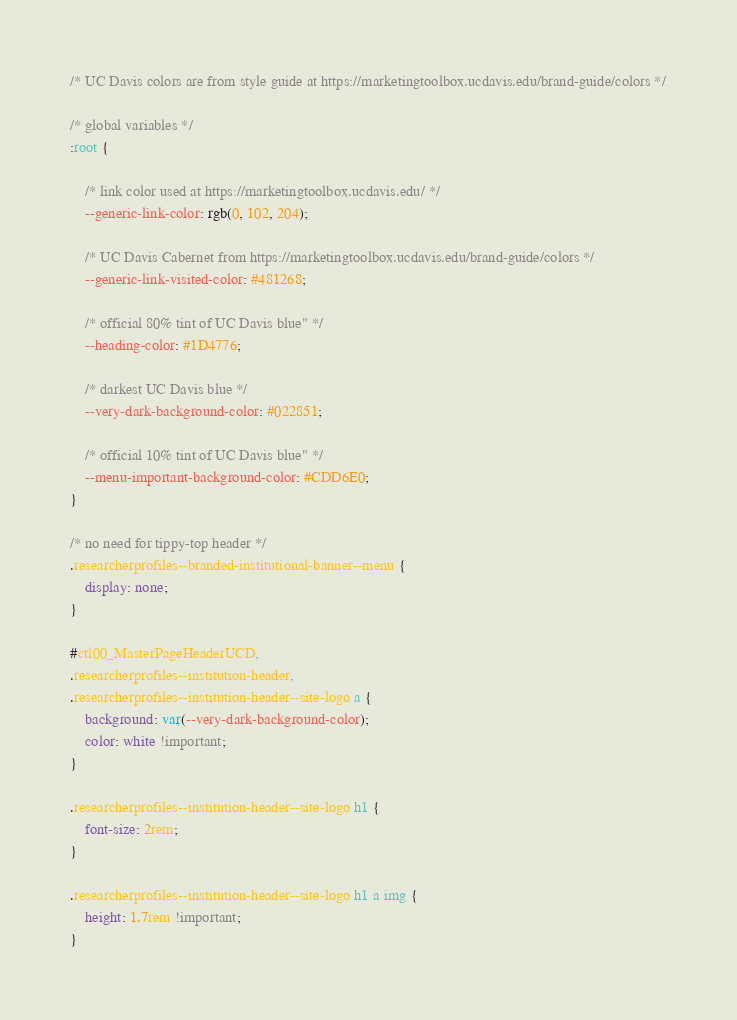Convert code to text. <code><loc_0><loc_0><loc_500><loc_500><_CSS_>/* UC Davis colors are from style guide at https://marketingtoolbox.ucdavis.edu/brand-guide/colors */

/* global variables */
:root {

    /* link color used at https://marketingtoolbox.ucdavis.edu/ */
    --generic-link-color: rgb(0, 102, 204);

    /* UC Davis Cabernet from https://marketingtoolbox.ucdavis.edu/brand-guide/colors */
    --generic-link-visited-color: #481268;

    /* official 80% tint of UC Davis blue" */
    --heading-color: #1D4776;

    /* darkest UC Davis blue */
    --very-dark-background-color: #022851;

    /* official 10% tint of UC Davis blue" */
    --menu-important-background-color: #CDD6E0;
}

/* no need for tippy-top header */
.researcherprofiles--branded-institutional-banner--menu {
    display: none;
}

#ctl00_MasterPageHeaderUCD,
.researcherprofiles--institution-header,
.researcherprofiles--institution-header--site-logo a {
    background: var(--very-dark-background-color);
    color: white !important;
}

.researcherprofiles--institution-header--site-logo h1 {
    font-size: 2rem;
}

.researcherprofiles--institution-header--site-logo h1 a img {
    height: 1.7rem !important;
}</code> 